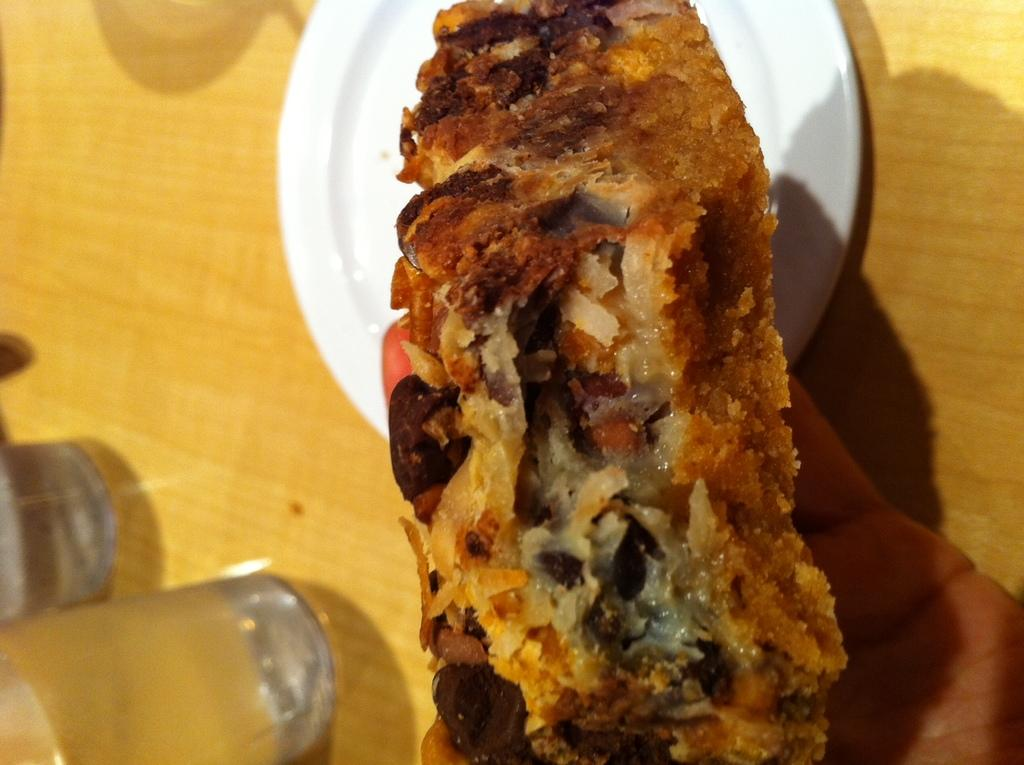What is the hand holding in the image? The hand is holding a bread item in the image. What is the bread item resting on? There is a plate in the image. What else can be seen on the table in the image? There are glasses on the table in the image. Can you describe the waves in the lake visible in the image? There is no lake or waves present in the image; it features a hand holding a bread item, a plate, and glasses on a table. 